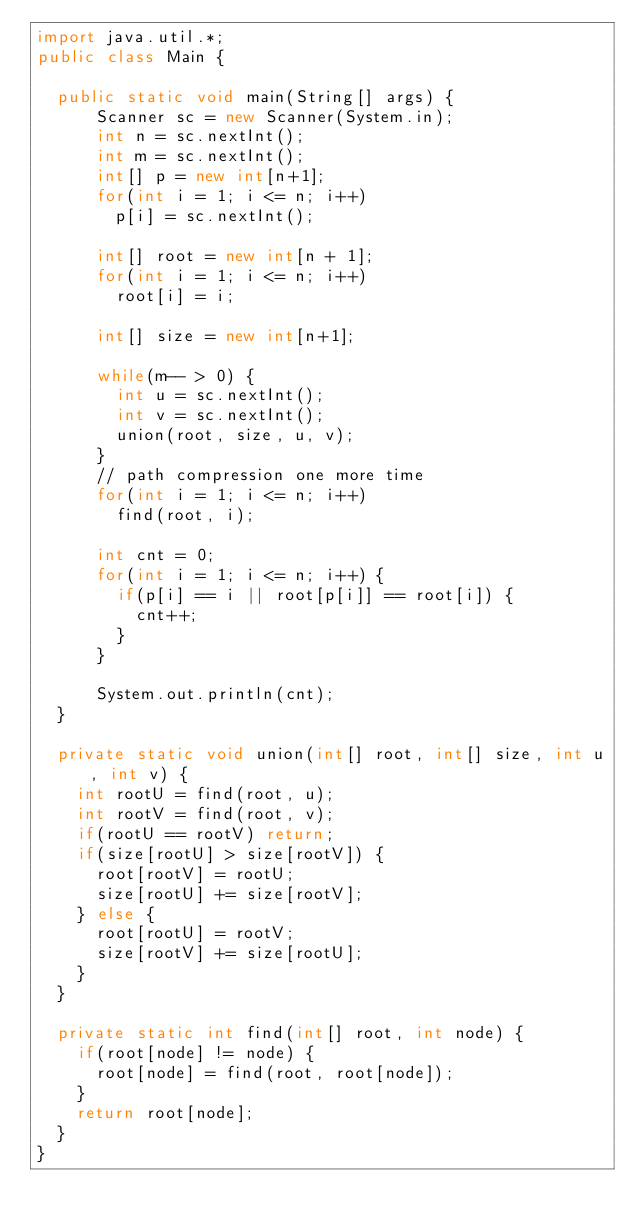<code> <loc_0><loc_0><loc_500><loc_500><_Java_>import java.util.*;
public class Main {

  public static void main(String[] args) { 
      Scanner sc = new Scanner(System.in);
      int n = sc.nextInt();
      int m = sc.nextInt();
      int[] p = new int[n+1];
      for(int i = 1; i <= n; i++)
        p[i] = sc.nextInt();

      int[] root = new int[n + 1];
      for(int i = 1; i <= n; i++)
        root[i] = i;

      int[] size = new int[n+1];

      while(m-- > 0) {
        int u = sc.nextInt();
        int v = sc.nextInt();
        union(root, size, u, v);
      }
      // path compression one more time
      for(int i = 1; i <= n; i++)
        find(root, i);
        
      int cnt = 0;
      for(int i = 1; i <= n; i++) {
        if(p[i] == i || root[p[i]] == root[i]) {
          cnt++;
        }
      }

      System.out.println(cnt);
  }
 
  private static void union(int[] root, int[] size, int u, int v) {
    int rootU = find(root, u);
    int rootV = find(root, v);
    if(rootU == rootV) return;
    if(size[rootU] > size[rootV]) {
      root[rootV] = rootU;
      size[rootU] += size[rootV];
    } else {
      root[rootU] = rootV;
      size[rootV] += size[rootU];
    }
  }

  private static int find(int[] root, int node) {
    if(root[node] != node) {
      root[node] = find(root, root[node]);
    }
    return root[node];
  }
}</code> 